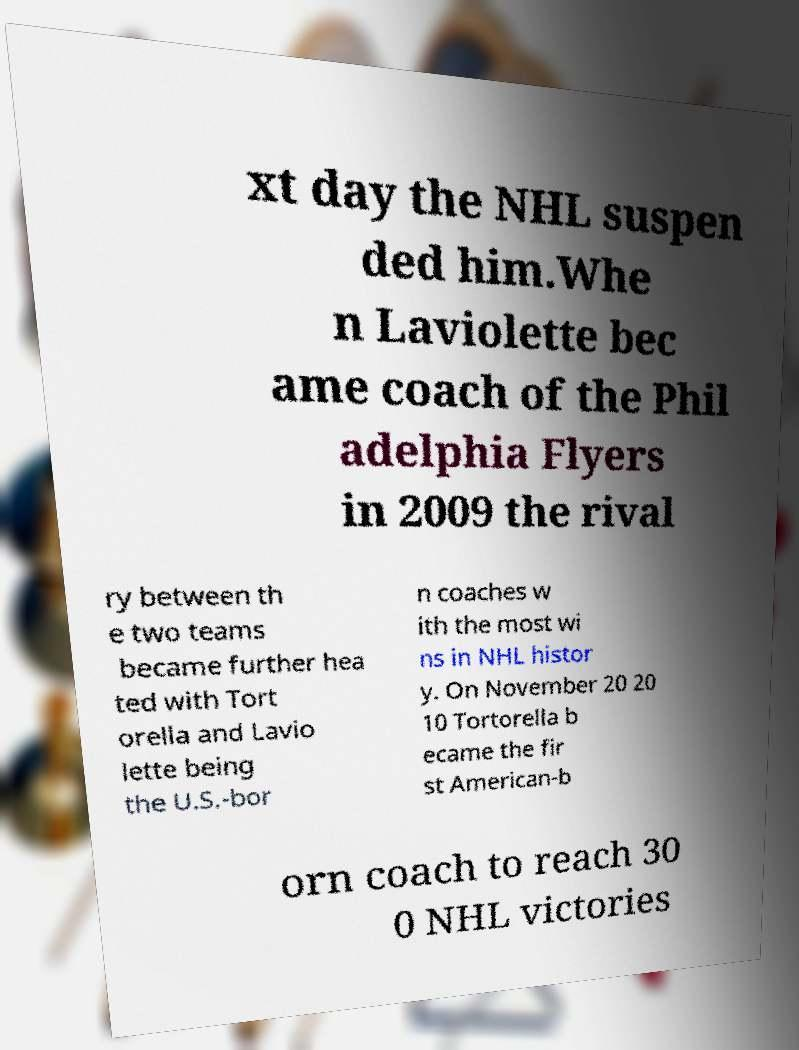There's text embedded in this image that I need extracted. Can you transcribe it verbatim? xt day the NHL suspen ded him.Whe n Laviolette bec ame coach of the Phil adelphia Flyers in 2009 the rival ry between th e two teams became further hea ted with Tort orella and Lavio lette being the U.S.-bor n coaches w ith the most wi ns in NHL histor y. On November 20 20 10 Tortorella b ecame the fir st American-b orn coach to reach 30 0 NHL victories 